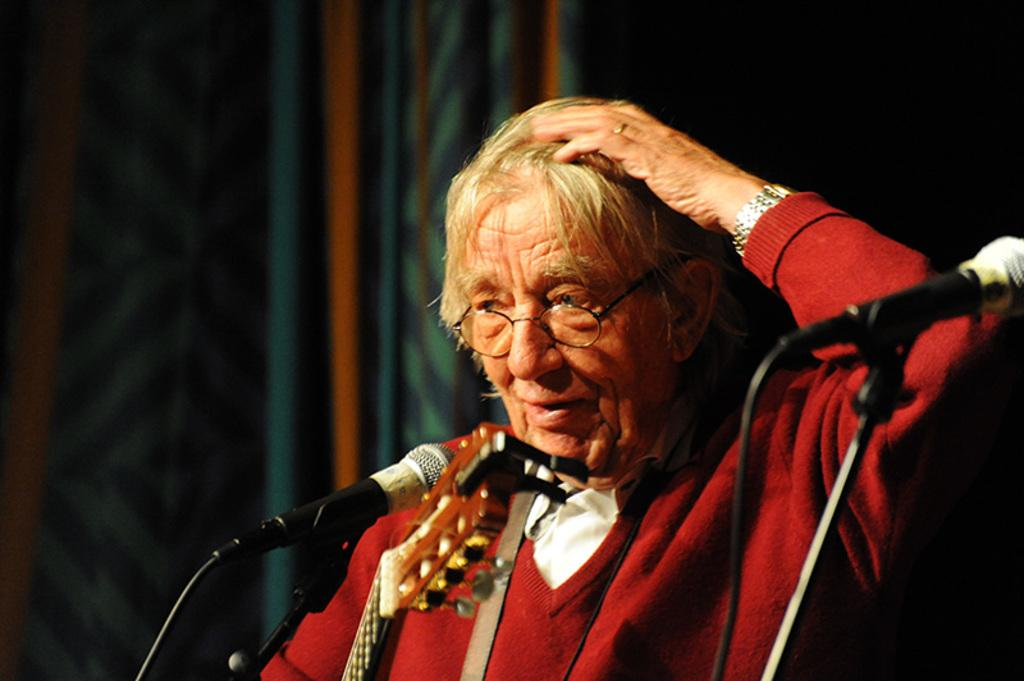What can be seen on the person in the image? The person in the image is wearing spectacles. What objects are present in the image that are related to sound? There are microphones with stands in the image. What type of musical instrument is visible at the bottom of the image? There is a musical instrument at the bottom of the image, but the specific type cannot be determined from the provided facts. How would you describe the background of the image? The background of the image is blurry. Is there a ghost visible in the image? No, there is no ghost present in the image. What type of farming equipment can be seen in the image? There is no farming equipment present in the image. 